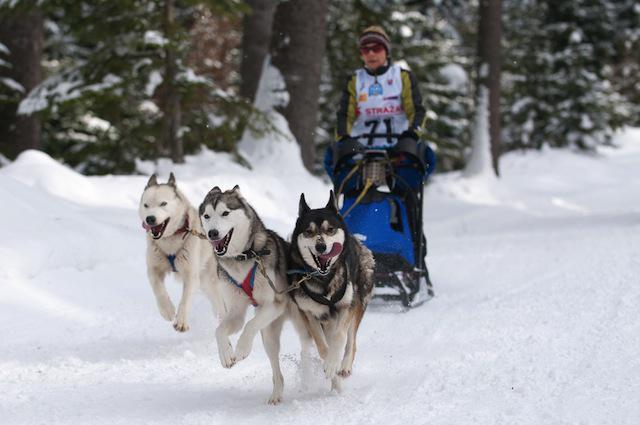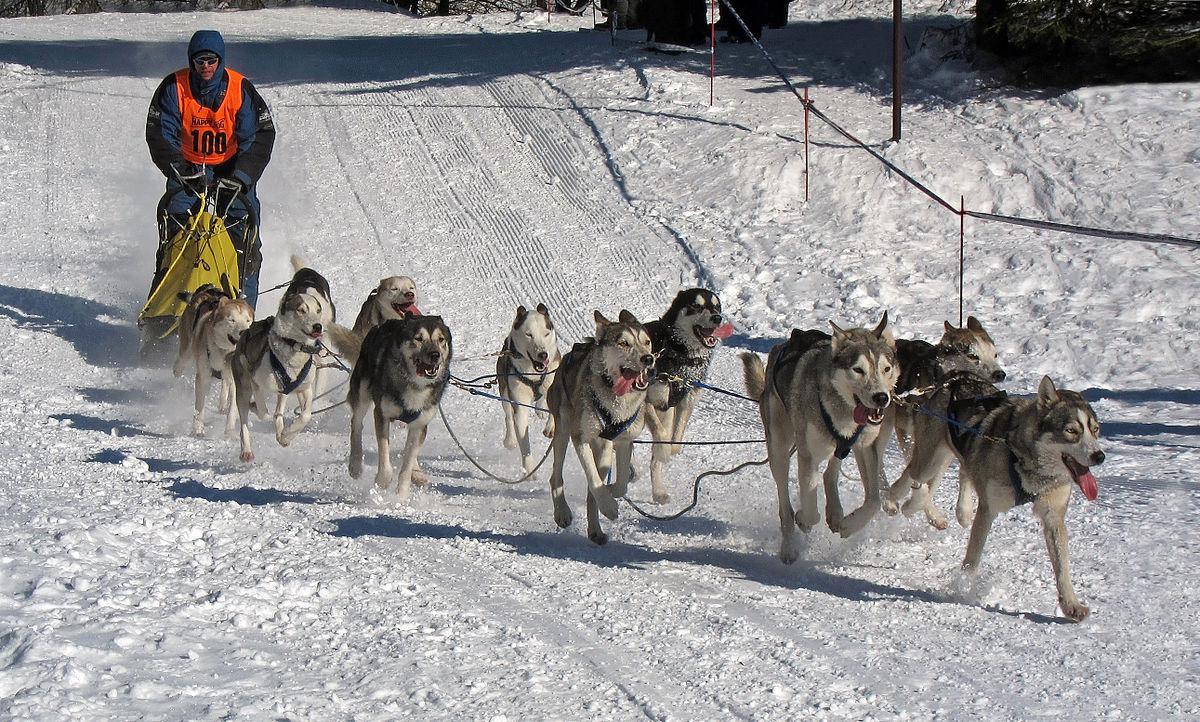The first image is the image on the left, the second image is the image on the right. Given the left and right images, does the statement "One of the sleds is pulled by no more than 3 dogs." hold true? Answer yes or no. Yes. The first image is the image on the left, the second image is the image on the right. Assess this claim about the two images: "The person in the sled in the image on the left is wearing a white numbered vest.". Correct or not? Answer yes or no. Yes. 